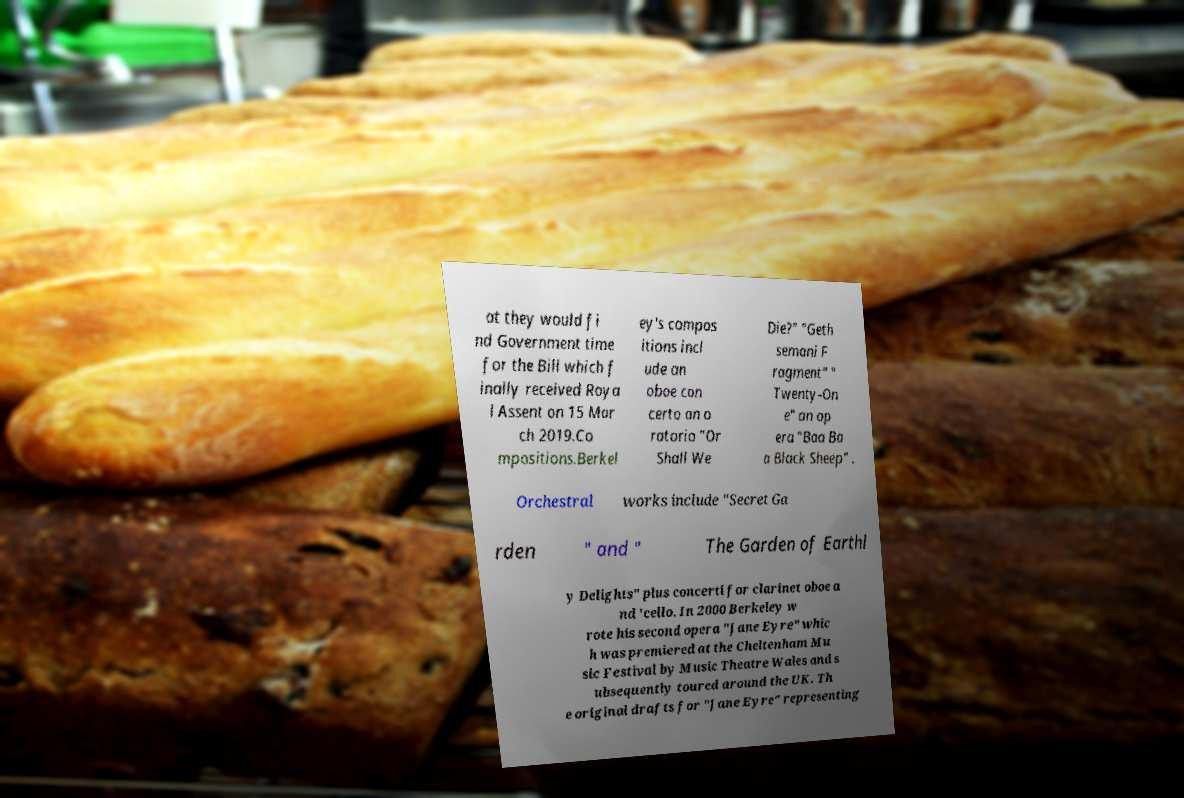Can you accurately transcribe the text from the provided image for me? at they would fi nd Government time for the Bill which f inally received Roya l Assent on 15 Mar ch 2019.Co mpositions.Berkel ey's compos itions incl ude an oboe con certo an o ratorio "Or Shall We Die?" "Geth semani F ragment" " Twenty-On e" an op era "Baa Ba a Black Sheep" . Orchestral works include "Secret Ga rden " and " The Garden of Earthl y Delights" plus concerti for clarinet oboe a nd 'cello. In 2000 Berkeley w rote his second opera "Jane Eyre" whic h was premiered at the Cheltenham Mu sic Festival by Music Theatre Wales and s ubsequently toured around the UK. Th e original drafts for "Jane Eyre" representing 